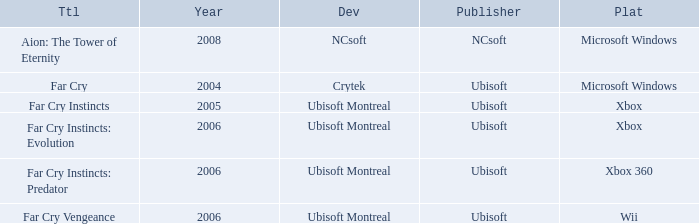Which title has a year prior to 2008 and xbox 360 as the platform? Far Cry Instincts: Predator. 